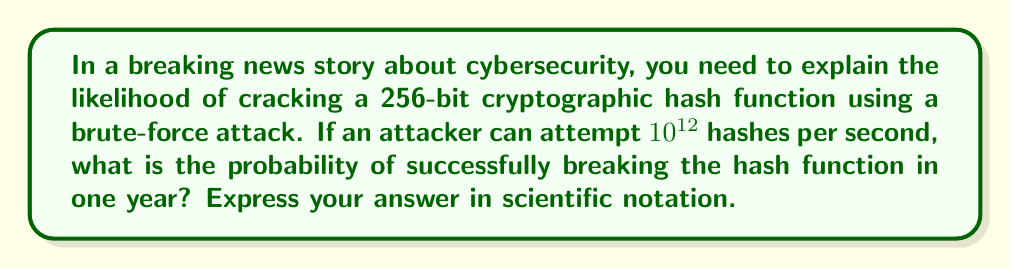Give your solution to this math problem. To solve this problem, we'll follow these steps:

1) First, calculate the total number of possible hash values:
   For a 256-bit hash, there are $2^{256}$ possible values.

2) Calculate the number of hash attempts in one year:
   - Attempts per second: $10^{12}$
   - Seconds in a year: $365 \times 24 \times 60 \times 60 = 31,536,000$
   - Total attempts in a year: $10^{12} \times 31,536,000 = 3.1536 \times 10^{19}$

3) The probability of success is the number of attempts divided by the total number of possible hash values:

   $$P(\text{success}) = \frac{\text{Number of attempts}}{\text{Total possible hash values}}$$

   $$P(\text{success}) = \frac{3.1536 \times 10^{19}}{2^{256}}$$

4) To simplify this, we can convert $2^{256}$ to base 10:
   $2^{256} \approx 1.1579 \times 10^{77}$

5) Now we can divide:

   $$P(\text{success}) = \frac{3.1536 \times 10^{19}}{1.1579 \times 10^{77}} \approx 2.7235 \times 10^{-58}$$

This extremely small probability demonstrates the strength of 256-bit cryptographic hash functions against brute-force attacks.
Answer: $2.7235 \times 10^{-58}$ 